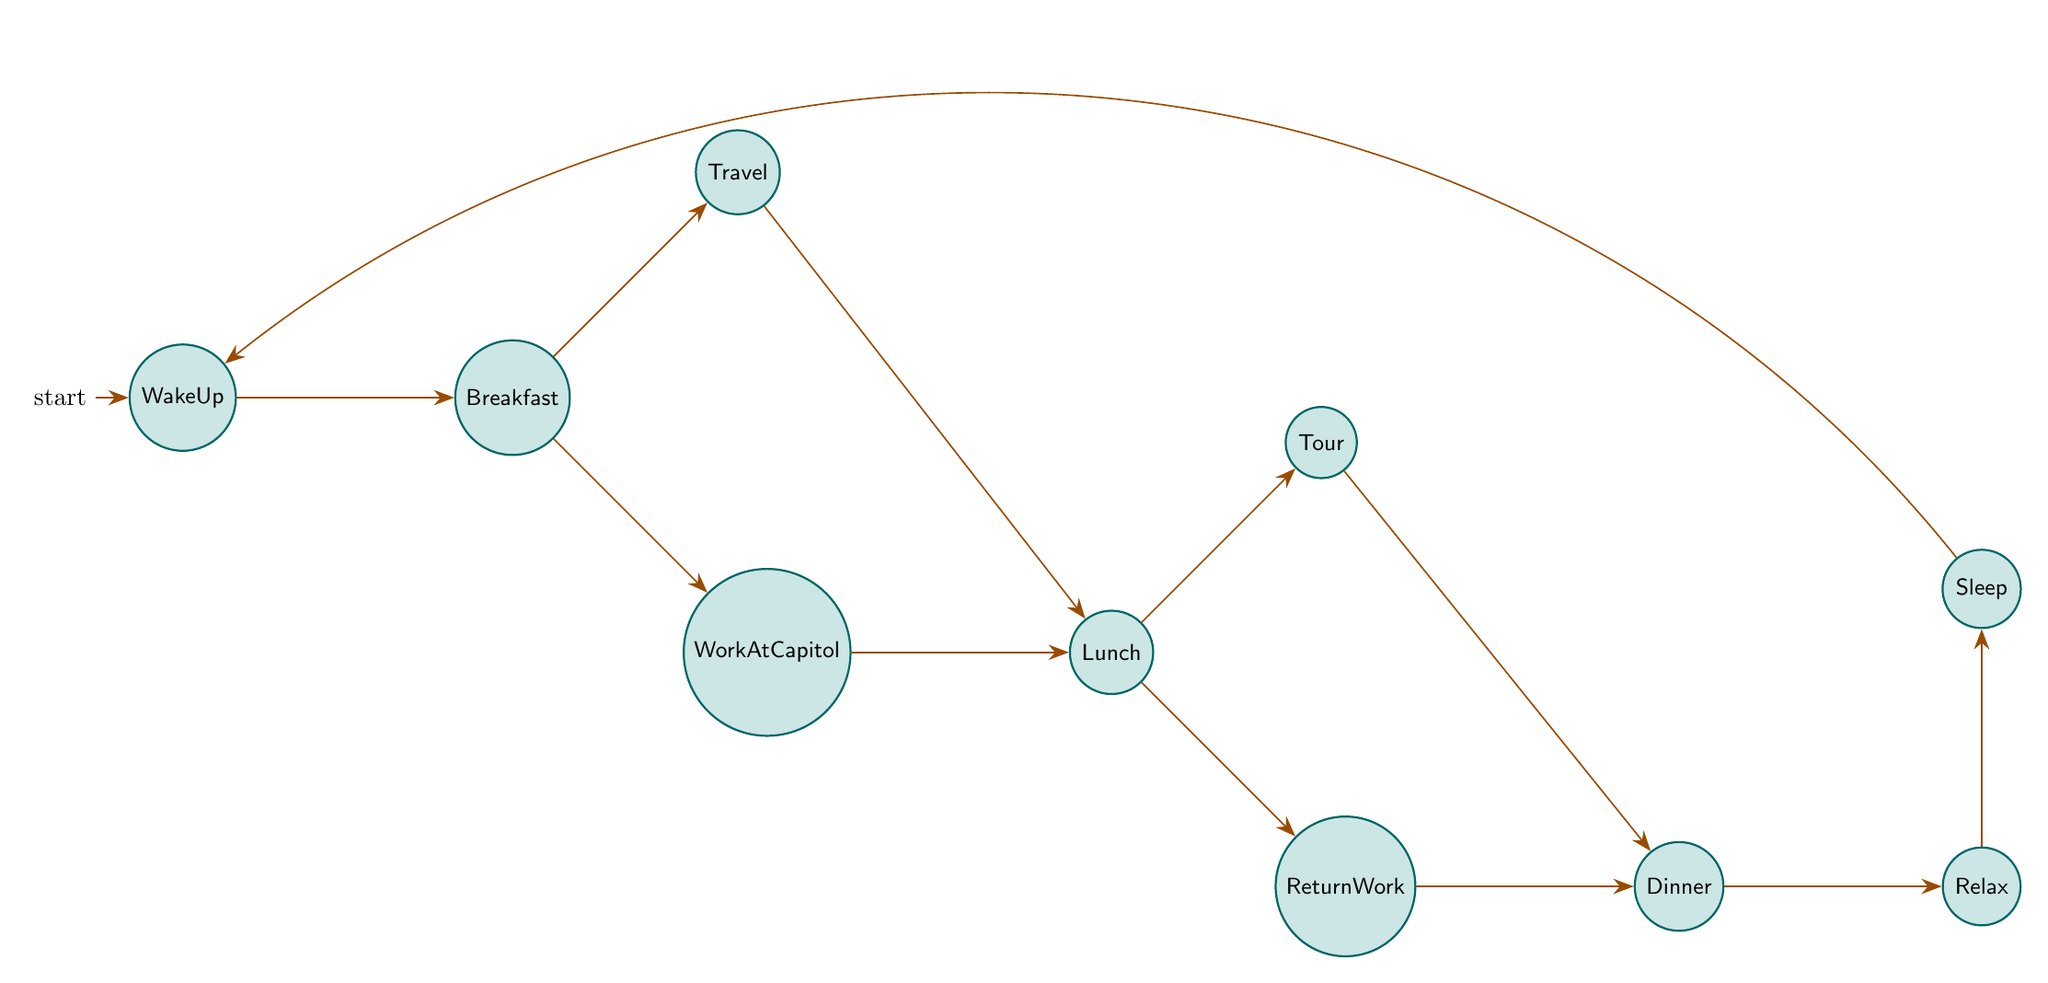What is the initial state in the diagram? The diagram begins with the "WakeUp" state, which is indicated as the starting point for the daily routine.
Answer: WakeUp How many states are there in the diagram? Counting all the nodes from "WakeUp" to "Sleep", there are 10 distinct states in total.
Answer: 10 What activity follows "Lunch" if one chooses to continue the daily routine? From the "Lunch" state, you can transition to either "ReturnWork" or "Tour", meaning both are possible next activities after lunch.
Answer: ReturnWork or Tour What is the final activity in the daily routine? The last state in the diagram is "Relax", which occurs after "Dinner", and then it transitions to "Sleep".
Answer: Relax If someone travels to a speaking engagement, what is the next possible activity? Upon completing the "Travel" activity, the next step leads to "Lunch", highlighting that lunch follows after traveling.
Answer: Lunch What is the relationship between "Travel" and "Lunch"? "Travel" transitions directly to "Lunch", indicating that after traveling, the next activity is to have lunch.
Answer: Lunch How does one return to their work after lunch? After having lunch at the local restaurant, the next state is "ReturnWork," which indicates the transition back to work.
Answer: ReturnWork What activity comes immediately after "Dinner"? Following "Dinner," the next activity is "Relax," which shows that relaxation comes after dining.
Answer: Relax Which state has two possible transitions leading out of it? The "Lunch" state has two possible transitions to "ReturnWork" and "Tour," making it a point from which two different activities can follow.
Answer: Lunch What state ends the daily routine before it starts again? The routine concludes with the "Sleep" state before transitioning back to the beginning state, "WakeUp."
Answer: Sleep 